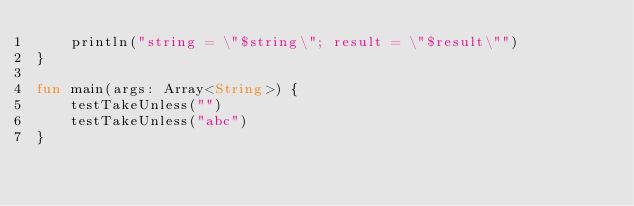Convert code to text. <code><loc_0><loc_0><loc_500><loc_500><_Kotlin_>    println("string = \"$string\"; result = \"$result\"")
}

fun main(args: Array<String>) {
    testTakeUnless("")
    testTakeUnless("abc")
}</code> 